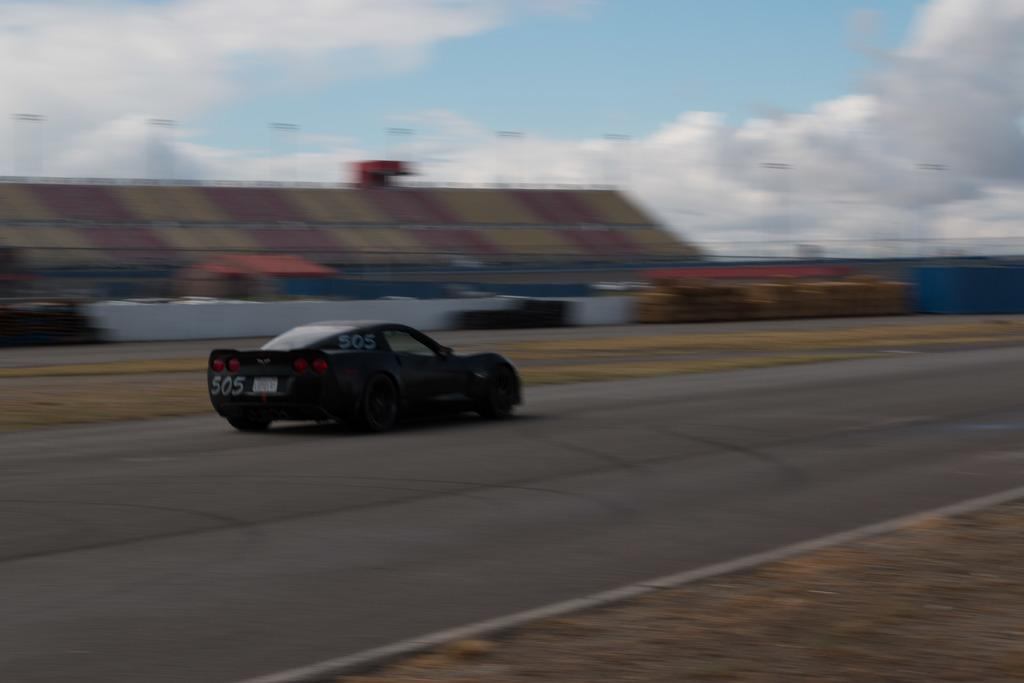What is the main subject of the image? There is a vehicle on the road in the image. What can be seen in the background of the image? There are sheds in the background of the image. What is visible in the sky at the top of the image? There are clouds visible in the sky at the top of the image. How many carts are being folded in the image? There are no carts present in the image, and therefore no folding activity can be observed. 